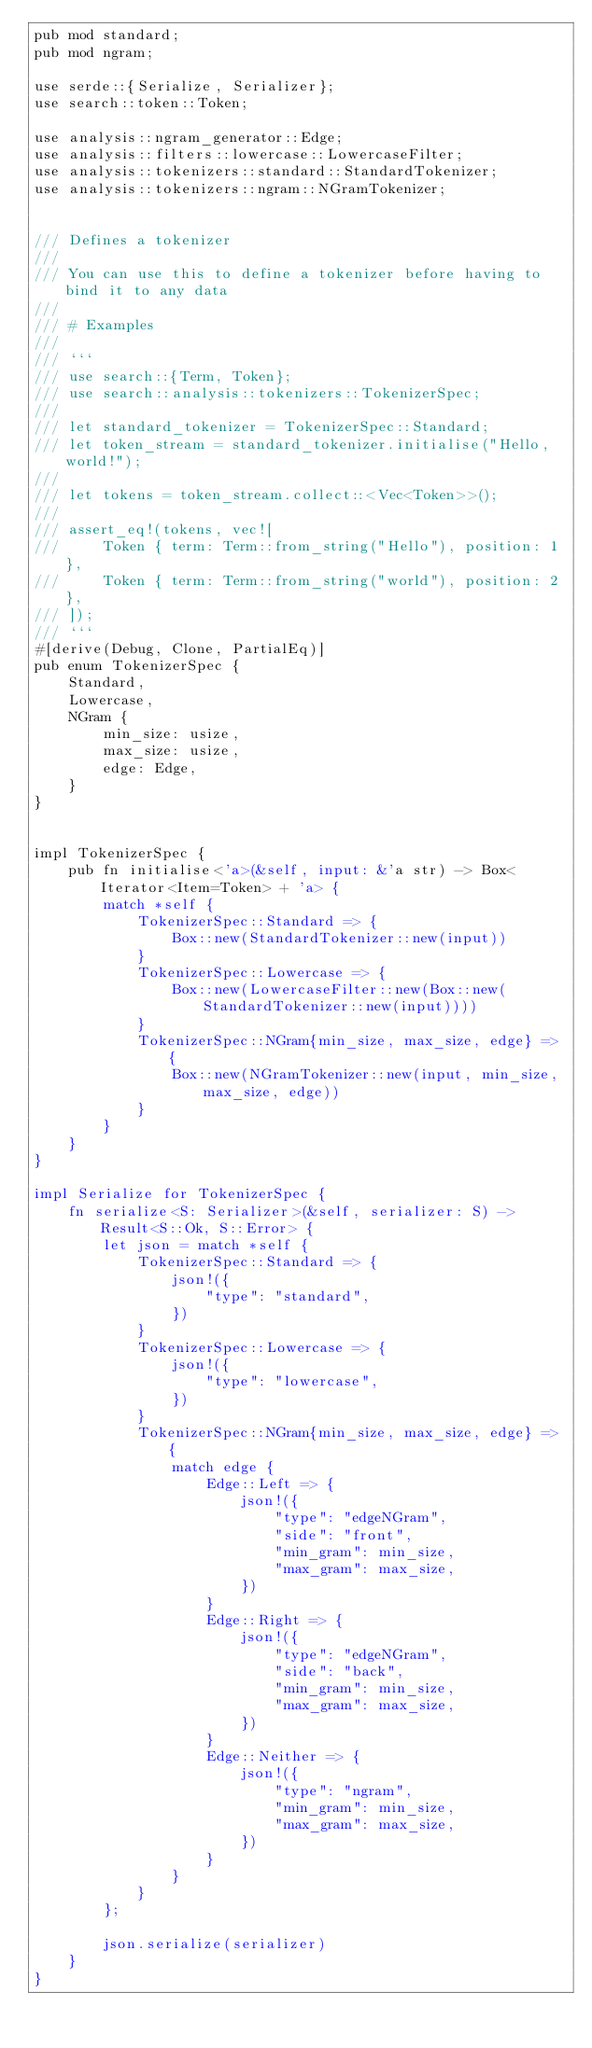<code> <loc_0><loc_0><loc_500><loc_500><_Rust_>pub mod standard;
pub mod ngram;

use serde::{Serialize, Serializer};
use search::token::Token;

use analysis::ngram_generator::Edge;
use analysis::filters::lowercase::LowercaseFilter;
use analysis::tokenizers::standard::StandardTokenizer;
use analysis::tokenizers::ngram::NGramTokenizer;


/// Defines a tokenizer
///
/// You can use this to define a tokenizer before having to bind it to any data
///
/// # Examples
///
/// ```
/// use search::{Term, Token};
/// use search::analysis::tokenizers::TokenizerSpec;
///
/// let standard_tokenizer = TokenizerSpec::Standard;
/// let token_stream = standard_tokenizer.initialise("Hello, world!");
///
/// let tokens = token_stream.collect::<Vec<Token>>();
///
/// assert_eq!(tokens, vec![
///     Token { term: Term::from_string("Hello"), position: 1 },
///     Token { term: Term::from_string("world"), position: 2 },
/// ]);
/// ```
#[derive(Debug, Clone, PartialEq)]
pub enum TokenizerSpec {
    Standard,
    Lowercase,
    NGram {
        min_size: usize,
        max_size: usize,
        edge: Edge,
    }
}


impl TokenizerSpec {
    pub fn initialise<'a>(&self, input: &'a str) -> Box<Iterator<Item=Token> + 'a> {
        match *self {
            TokenizerSpec::Standard => {
                Box::new(StandardTokenizer::new(input))
            }
            TokenizerSpec::Lowercase => {
                Box::new(LowercaseFilter::new(Box::new(StandardTokenizer::new(input))))
            }
            TokenizerSpec::NGram{min_size, max_size, edge} => {
                Box::new(NGramTokenizer::new(input, min_size, max_size, edge))
            }
        }
    }
}

impl Serialize for TokenizerSpec {
    fn serialize<S: Serializer>(&self, serializer: S) -> Result<S::Ok, S::Error> {
        let json = match *self {
            TokenizerSpec::Standard => {
                json!({
                    "type": "standard",
                })
            }
            TokenizerSpec::Lowercase => {
                json!({
                    "type": "lowercase",
                })
            }
            TokenizerSpec::NGram{min_size, max_size, edge} => {
                match edge {
                    Edge::Left => {
                        json!({
                            "type": "edgeNGram",
                            "side": "front",
                            "min_gram": min_size,
                            "max_gram": max_size,
                        })
                    }
                    Edge::Right => {
                        json!({
                            "type": "edgeNGram",
                            "side": "back",
                            "min_gram": min_size,
                            "max_gram": max_size,
                        })
                    }
                    Edge::Neither => {
                        json!({
                            "type": "ngram",
                            "min_gram": min_size,
                            "max_gram": max_size,
                        })
                    }
                }
            }
        };

        json.serialize(serializer)
    }
}
</code> 